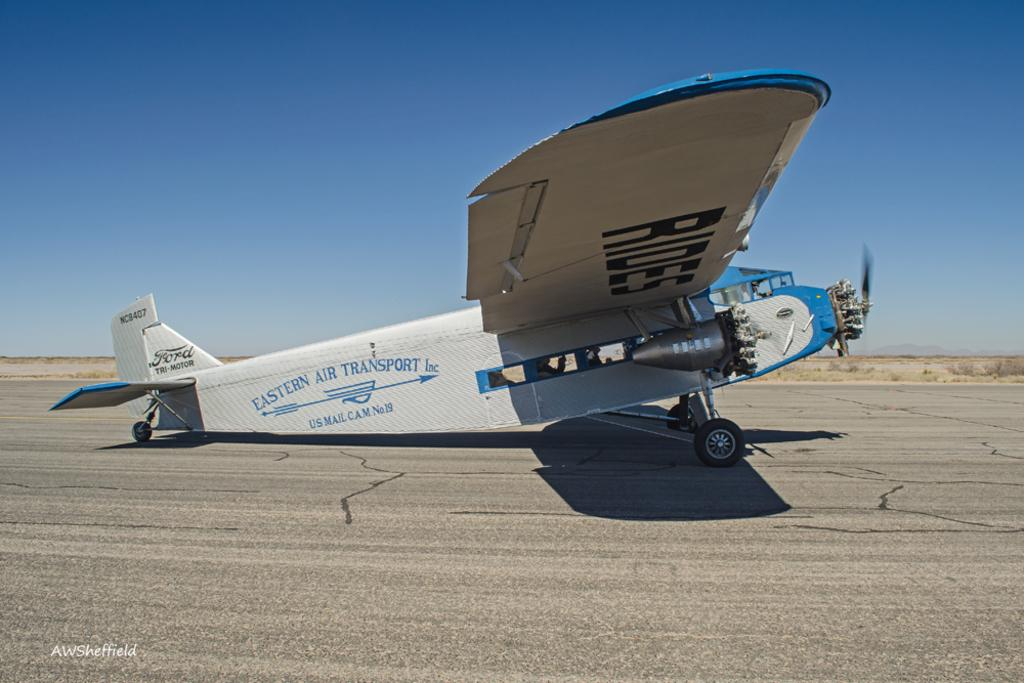What is the main subject of the image? The main subject of the image is an aircraft. Can you describe any additional features or elements in the image? There is a watermark in the bottom left corner of the image. What can be seen in the background of the image? The sky is visible at the top of the image. What theory is being proposed by the geese in the image? There are no geese present in the image, so no theory can be proposed by them. 